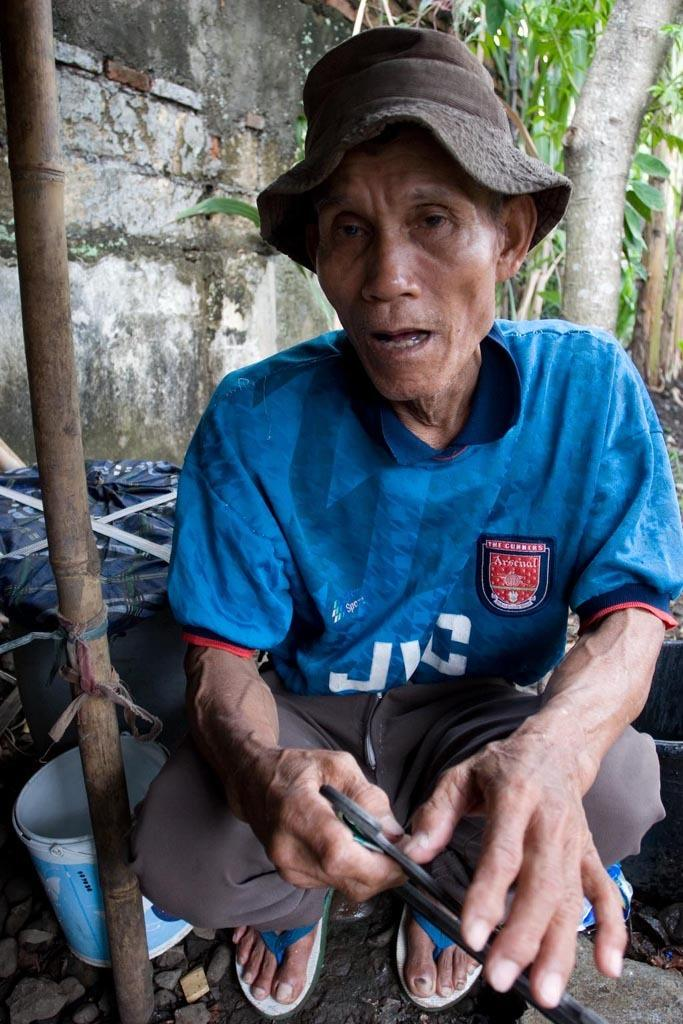What is the person in the image doing? There is a person sitting in the image. What is the person holding in his hand? The person is holding something in his hand. What can be seen behind the person? There is a tub behind the person. What type of natural environment is visible in the image? There are trees visible in the image. What type of structure is present in the image? There is a wall in the image. Where is the stick located in the image? There is a stick in the bottom left side of the image. How many mice are participating in the pie-eating competition in the image? There is no pie-eating competition or mice present in the image. 